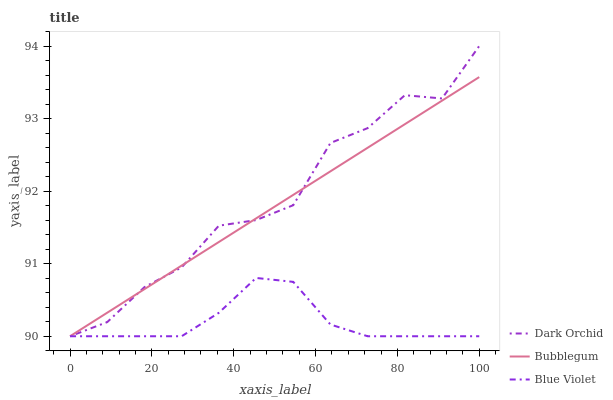Does Blue Violet have the minimum area under the curve?
Answer yes or no. Yes. Does Dark Orchid have the maximum area under the curve?
Answer yes or no. Yes. Does Bubblegum have the minimum area under the curve?
Answer yes or no. No. Does Bubblegum have the maximum area under the curve?
Answer yes or no. No. Is Bubblegum the smoothest?
Answer yes or no. Yes. Is Dark Orchid the roughest?
Answer yes or no. Yes. Is Dark Orchid the smoothest?
Answer yes or no. No. Is Bubblegum the roughest?
Answer yes or no. No. Does Blue Violet have the lowest value?
Answer yes or no. Yes. Does Dark Orchid have the highest value?
Answer yes or no. Yes. Does Bubblegum have the highest value?
Answer yes or no. No. Does Dark Orchid intersect Blue Violet?
Answer yes or no. Yes. Is Dark Orchid less than Blue Violet?
Answer yes or no. No. Is Dark Orchid greater than Blue Violet?
Answer yes or no. No. 